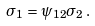Convert formula to latex. <formula><loc_0><loc_0><loc_500><loc_500>\sigma _ { 1 } = \psi _ { 1 2 } \sigma _ { 2 } \, .</formula> 